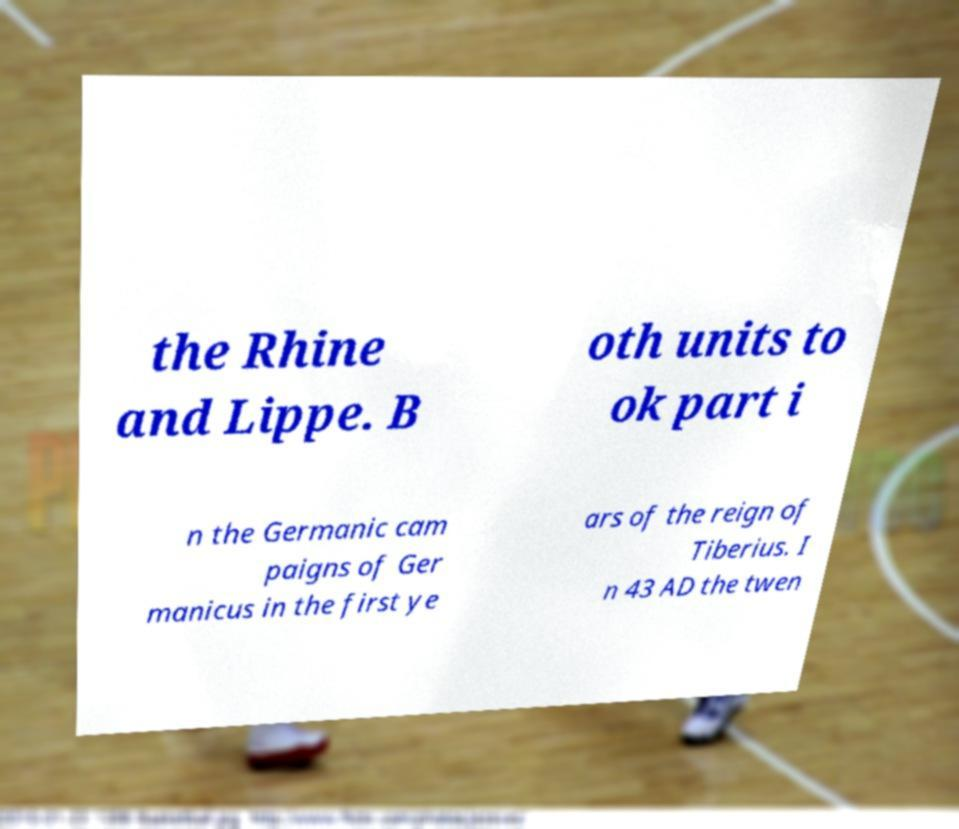Could you extract and type out the text from this image? the Rhine and Lippe. B oth units to ok part i n the Germanic cam paigns of Ger manicus in the first ye ars of the reign of Tiberius. I n 43 AD the twen 